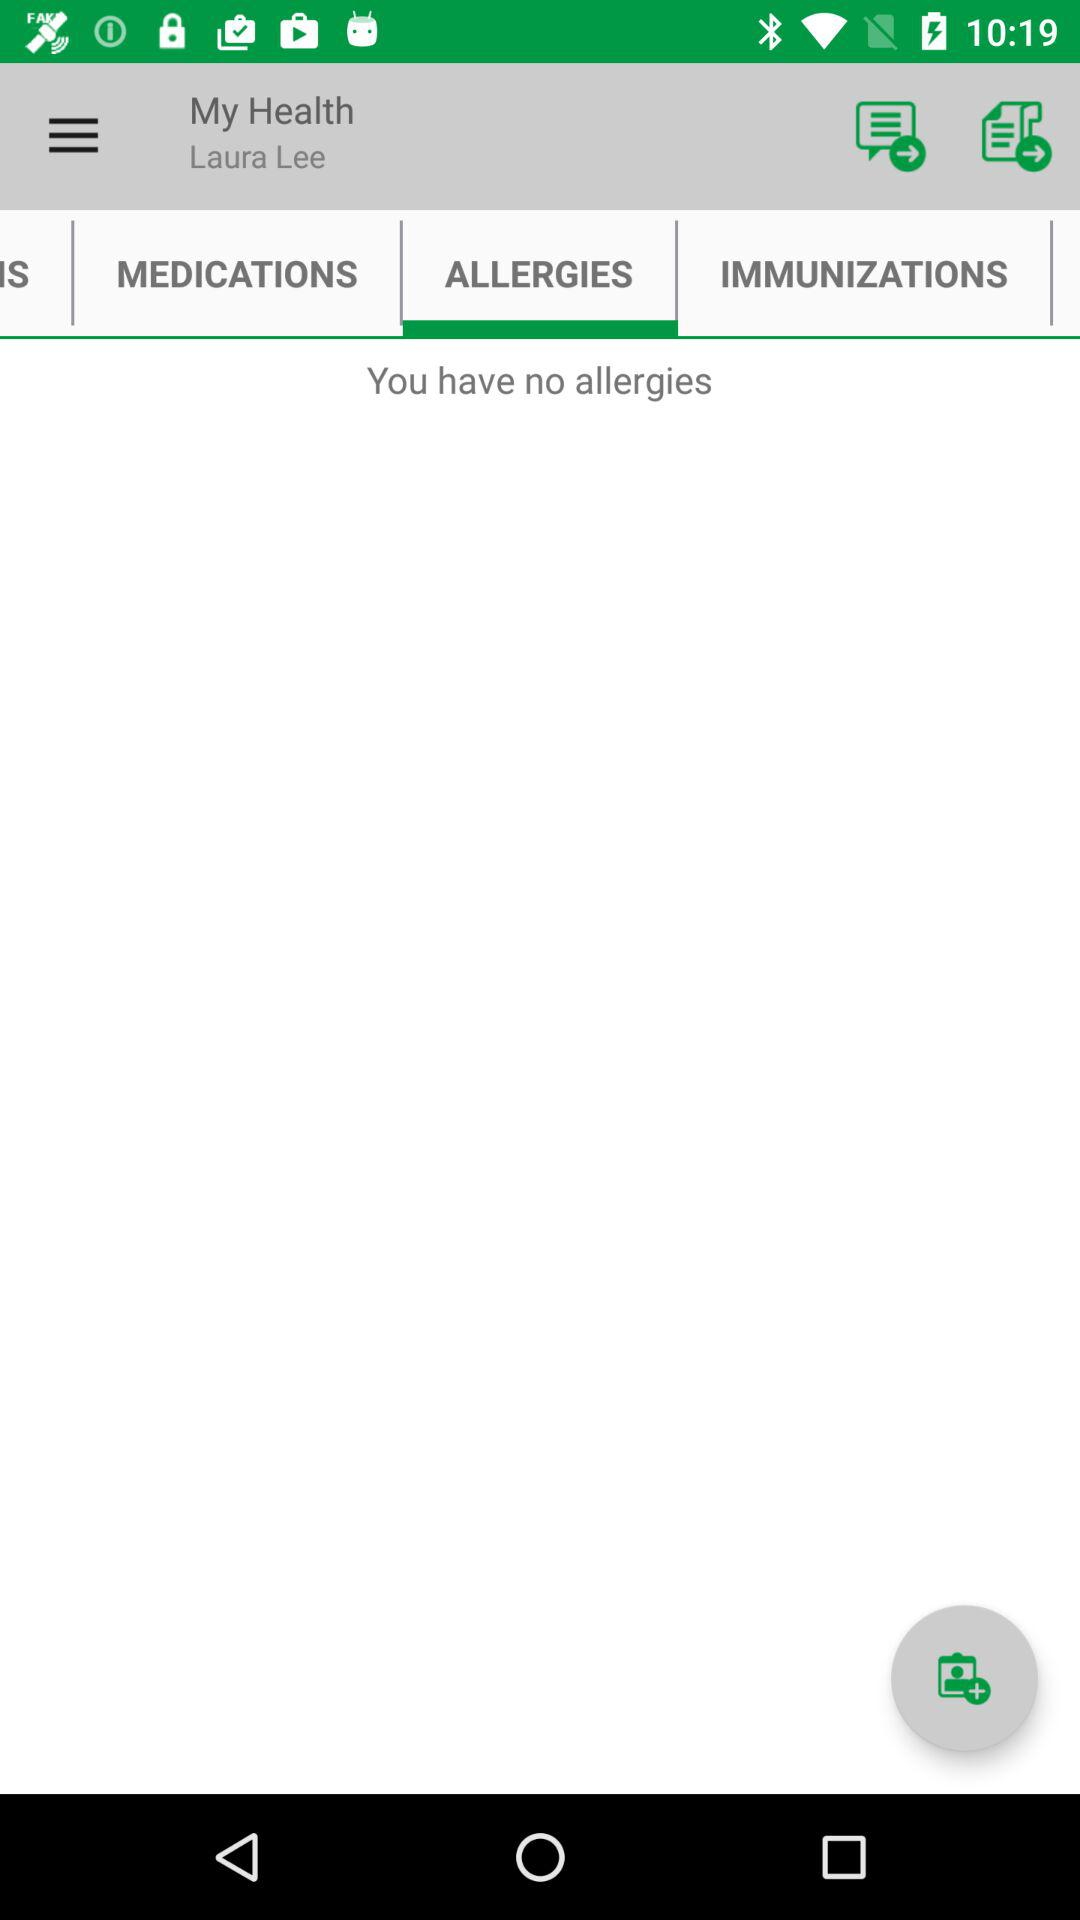What's the user name? The user name is Laura Lee. 